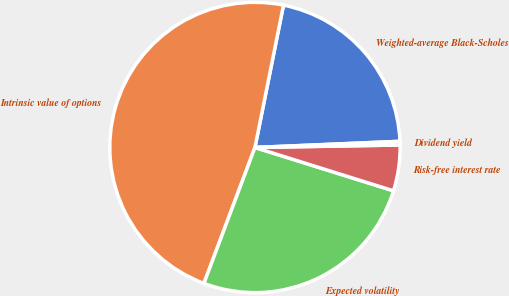Convert chart. <chart><loc_0><loc_0><loc_500><loc_500><pie_chart><fcel>Weighted-average Black-Scholes<fcel>Intrinsic value of options<fcel>Expected volatility<fcel>Risk-free interest rate<fcel>Dividend yield<nl><fcel>21.18%<fcel>47.44%<fcel>25.89%<fcel>5.1%<fcel>0.4%<nl></chart> 